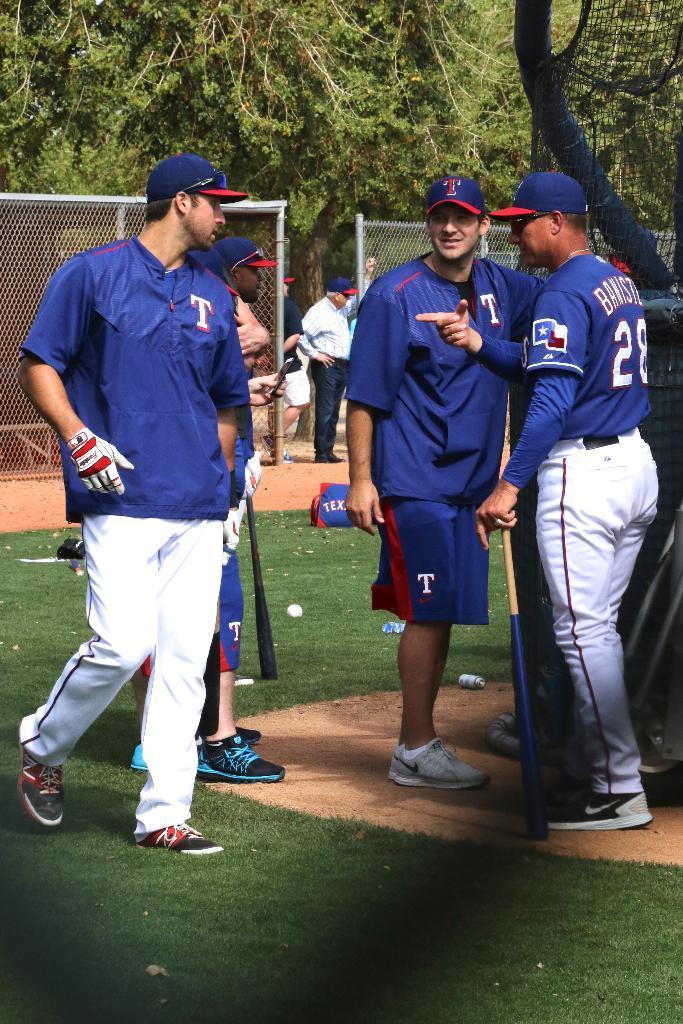Describe this image in one or two sentences. In this image I can see few persons wearing blue t shirts and blue caps are standing and few of them are holding bats in their hands. In the background I can see few persons standing, the metal fencing and few trees. 